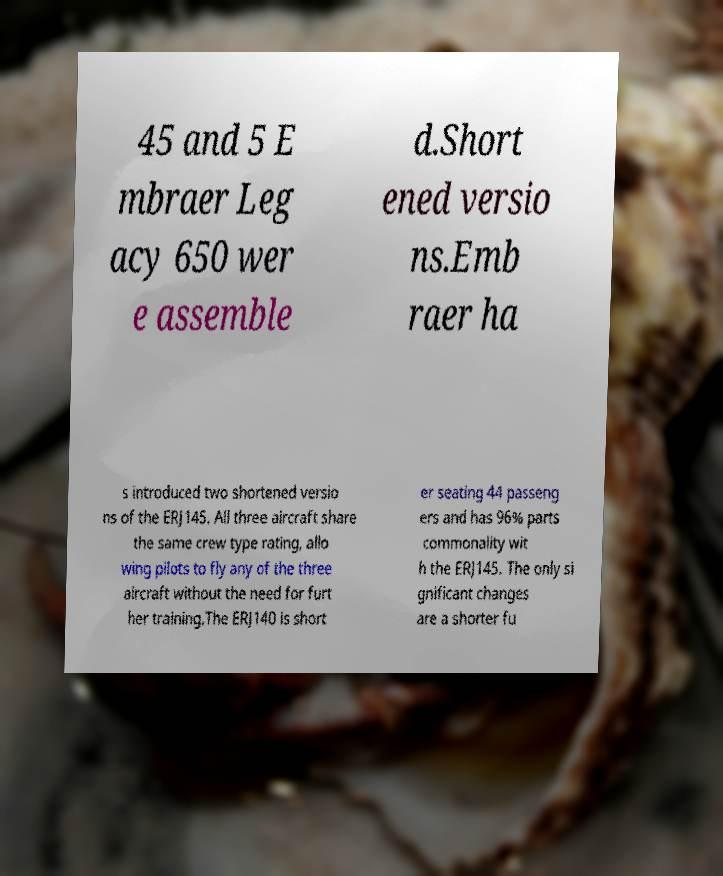For documentation purposes, I need the text within this image transcribed. Could you provide that? 45 and 5 E mbraer Leg acy 650 wer e assemble d.Short ened versio ns.Emb raer ha s introduced two shortened versio ns of the ERJ145. All three aircraft share the same crew type rating, allo wing pilots to fly any of the three aircraft without the need for furt her training.The ERJ140 is short er seating 44 passeng ers and has 96% parts commonality wit h the ERJ145. The only si gnificant changes are a shorter fu 